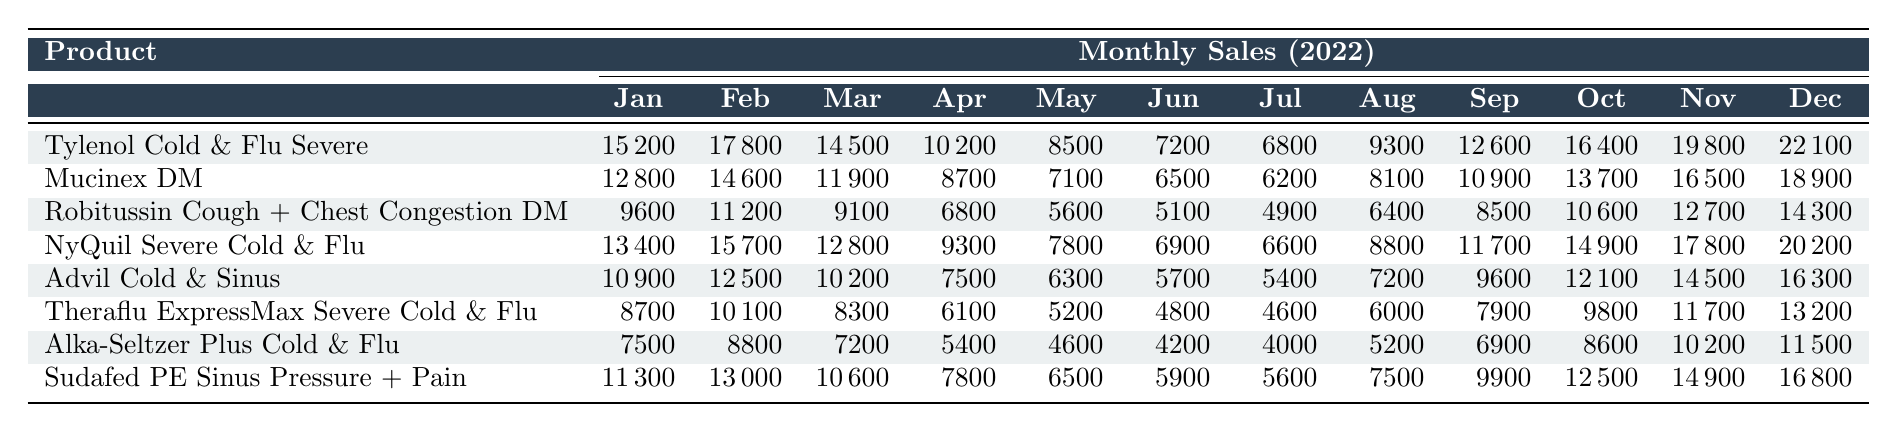What was the highest sales figure for "Tylenol Cold & Flu Severe" in 2022? The highest sales figure for "Tylenol Cold & Flu Severe" can be found in the last month (December), which shows a sales figure of 22,100.
Answer: 22,100 In which month did "Mucinex DM" experience the lowest sales? By checking the sales figures for each month, it is clear that "Mucinex DM" had its lowest sales in June, with 6,500 sales.
Answer: June What is the average monthly sales for "NyQuil Severe Cold & Flu" in 2022? To find the average, sum the sales figures for "NyQuil Severe Cold & Flu" (13400 + 15700 + 12800 + 9300 + 7800 + 6900 + 6600 + 8800 + 11700 + 14900 + 17800 + 20200) = 144,400. Then divide by 12 months to get the average: 144,400 / 12 = 12,033.
Answer: 12,033 Did "Robitussin Cough + Chest Congestion DM" have higher sales than "Alka-Seltzer Plus Cold & Flu" in any month? By comparing the sales figures month by month, "Robitussin Cough + Chest Congestion DM" had higher sales than "Alka-Seltzer Plus Cold & Flu" in every month except for December, where it had 14,300 compared to 11,500 for Alka-Seltzer.
Answer: No What is the total sales of "Sudafed PE Sinus Pressure + Pain" for the second half of the year? Add the sales from July to December for "Sudafed PE Sinus Pressure + Pain": (5,600 + 7,500 + 9,900 + 12,500 + 14,900 + 16,800) = 66,300.
Answer: 66,300 Which product had the second highest sales in December? Since we check the December sales for all products, "NyQuil Severe Cold & Flu" had the highest with 20,200 and "Tylenol Cold & Flu Severe" had the second highest with 22,100.
Answer: Tylenol Cold & Flu Severe What is the difference in sales between "Advil Cold & Sinus" in February and "Theraflu ExpressMax Severe Cold & Flu" in the same month? In February, "Advil Cold & Sinus" sold 12,500 units, while "Theraflu ExpressMax Severe Cold & Flu" sold 10,100 units. The difference is 12,500 - 10,100 = 2,400.
Answer: 2,400 What was the trend for "Theraflu ExpressMax Severe Cold & Flu" sales from January to June? Looking at the sales from January (8,700) to June (4,800), we can see a downward trend, as sales consistently decreased each month during this period.
Answer: Downward trend 